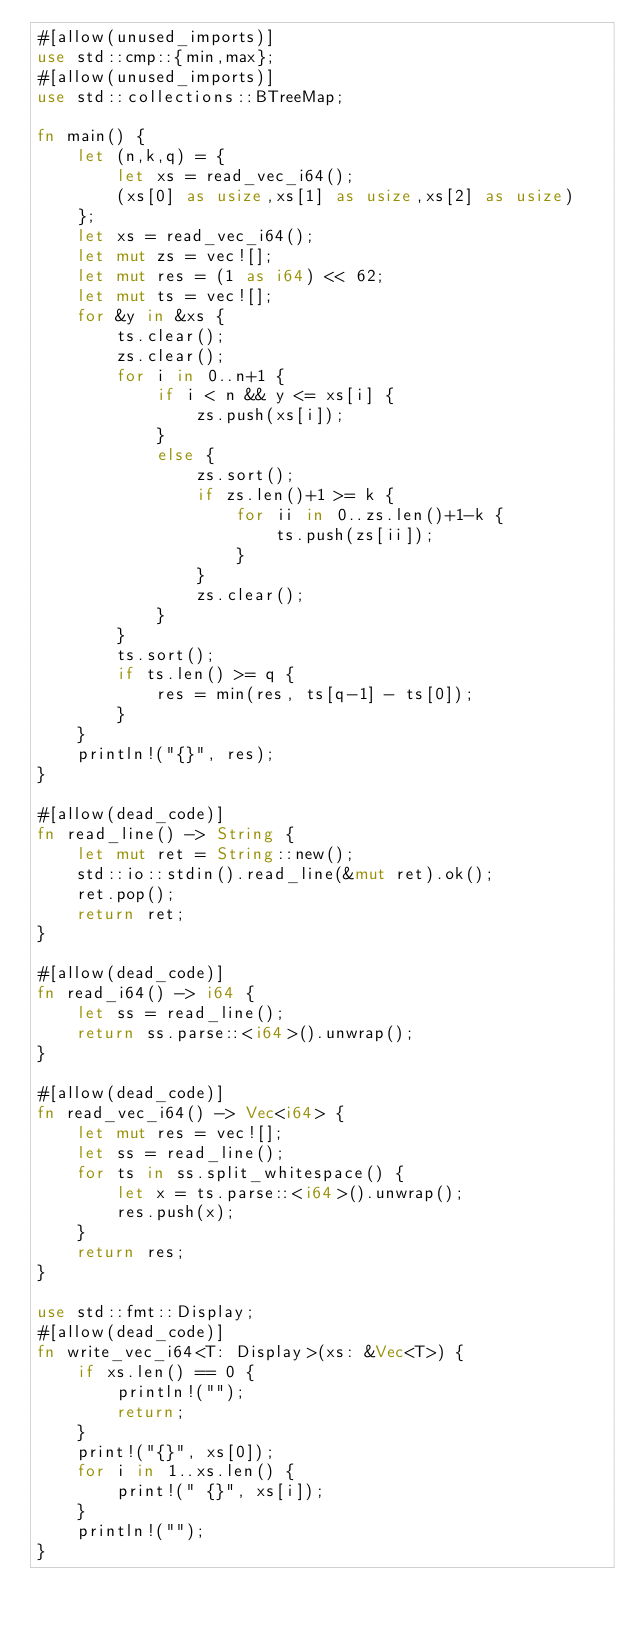Convert code to text. <code><loc_0><loc_0><loc_500><loc_500><_Rust_>#[allow(unused_imports)]
use std::cmp::{min,max};
#[allow(unused_imports)]
use std::collections::BTreeMap;

fn main() {
    let (n,k,q) = {
        let xs = read_vec_i64();
        (xs[0] as usize,xs[1] as usize,xs[2] as usize)
    };
    let xs = read_vec_i64();
    let mut zs = vec![];
    let mut res = (1 as i64) << 62;
    let mut ts = vec![];
    for &y in &xs {
        ts.clear();
        zs.clear();
        for i in 0..n+1 {
            if i < n && y <= xs[i] {
                zs.push(xs[i]);
            }
            else {
                zs.sort();
                if zs.len()+1 >= k {
                    for ii in 0..zs.len()+1-k {
                        ts.push(zs[ii]);
                    }
                }
                zs.clear();
            }
        }
        ts.sort();
        if ts.len() >= q {
            res = min(res, ts[q-1] - ts[0]);
        }
    }
    println!("{}", res);
}

#[allow(dead_code)]
fn read_line() -> String {
    let mut ret = String::new();
    std::io::stdin().read_line(&mut ret).ok();
    ret.pop();
    return ret;
}

#[allow(dead_code)]
fn read_i64() -> i64 {
    let ss = read_line();
    return ss.parse::<i64>().unwrap();
}

#[allow(dead_code)]
fn read_vec_i64() -> Vec<i64> {
    let mut res = vec![];
    let ss = read_line();
    for ts in ss.split_whitespace() {
        let x = ts.parse::<i64>().unwrap();
        res.push(x);
    }
    return res;
}

use std::fmt::Display;
#[allow(dead_code)]
fn write_vec_i64<T: Display>(xs: &Vec<T>) {
    if xs.len() == 0 {
        println!("");
        return;
    }
    print!("{}", xs[0]);
    for i in 1..xs.len() {
        print!(" {}", xs[i]);
    }
    println!("");
}
</code> 